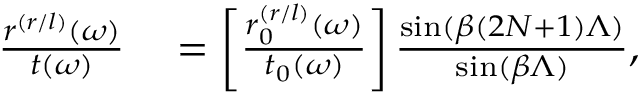Convert formula to latex. <formula><loc_0><loc_0><loc_500><loc_500>\begin{array} { r l } { \frac { r ^ { ( r / l ) } ( \omega ) } { t ( \omega ) } } & = \left [ \frac { r _ { 0 } ^ { ( r / l ) } ( \omega ) } { t _ { 0 } ( \omega ) } \right ] \frac { \sin ( \beta ( 2 N + 1 ) \Lambda ) } { \sin ( \beta \Lambda ) } , } \end{array}</formula> 